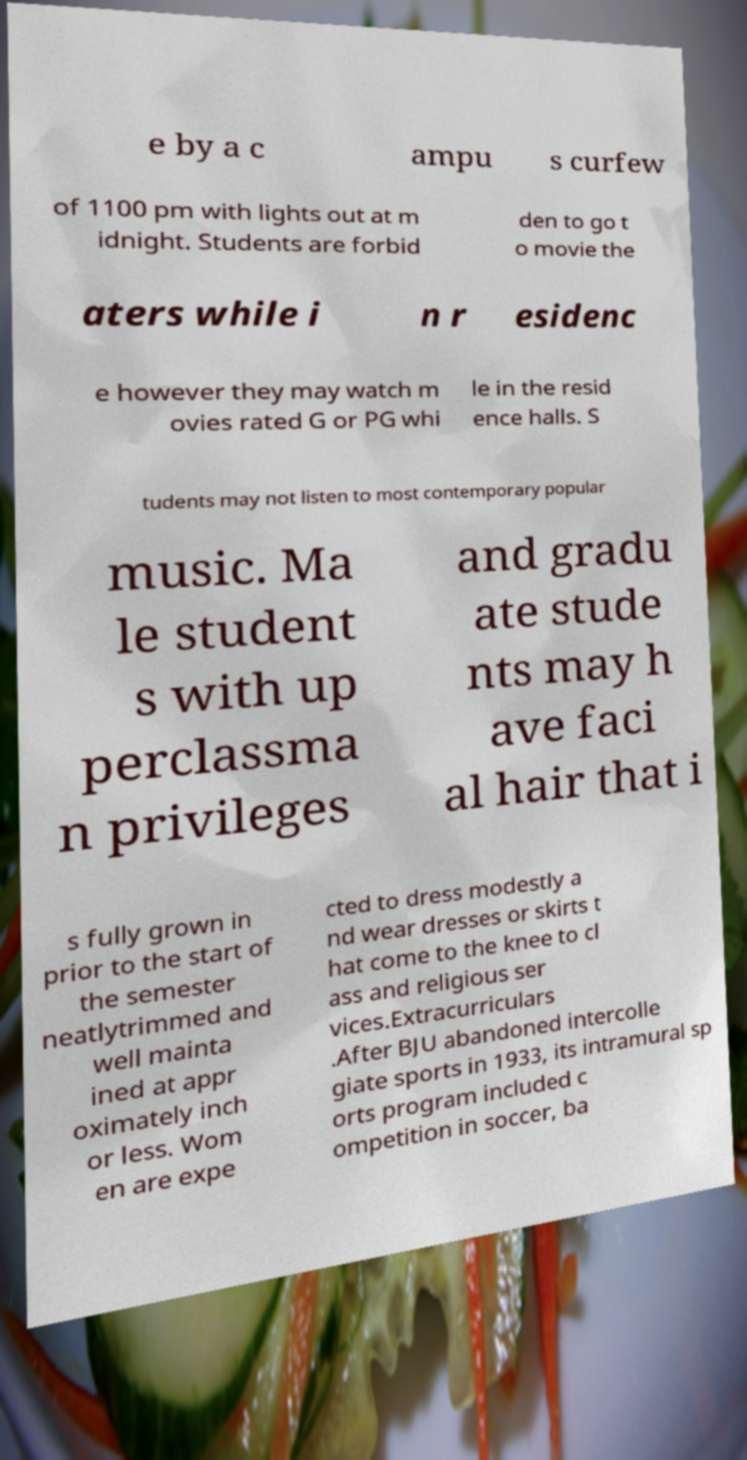Please read and relay the text visible in this image. What does it say? e by a c ampu s curfew of 1100 pm with lights out at m idnight. Students are forbid den to go t o movie the aters while i n r esidenc e however they may watch m ovies rated G or PG whi le in the resid ence halls. S tudents may not listen to most contemporary popular music. Ma le student s with up perclassma n privileges and gradu ate stude nts may h ave faci al hair that i s fully grown in prior to the start of the semester neatlytrimmed and well mainta ined at appr oximately inch or less. Wom en are expe cted to dress modestly a nd wear dresses or skirts t hat come to the knee to cl ass and religious ser vices.Extracurriculars .After BJU abandoned intercolle giate sports in 1933, its intramural sp orts program included c ompetition in soccer, ba 